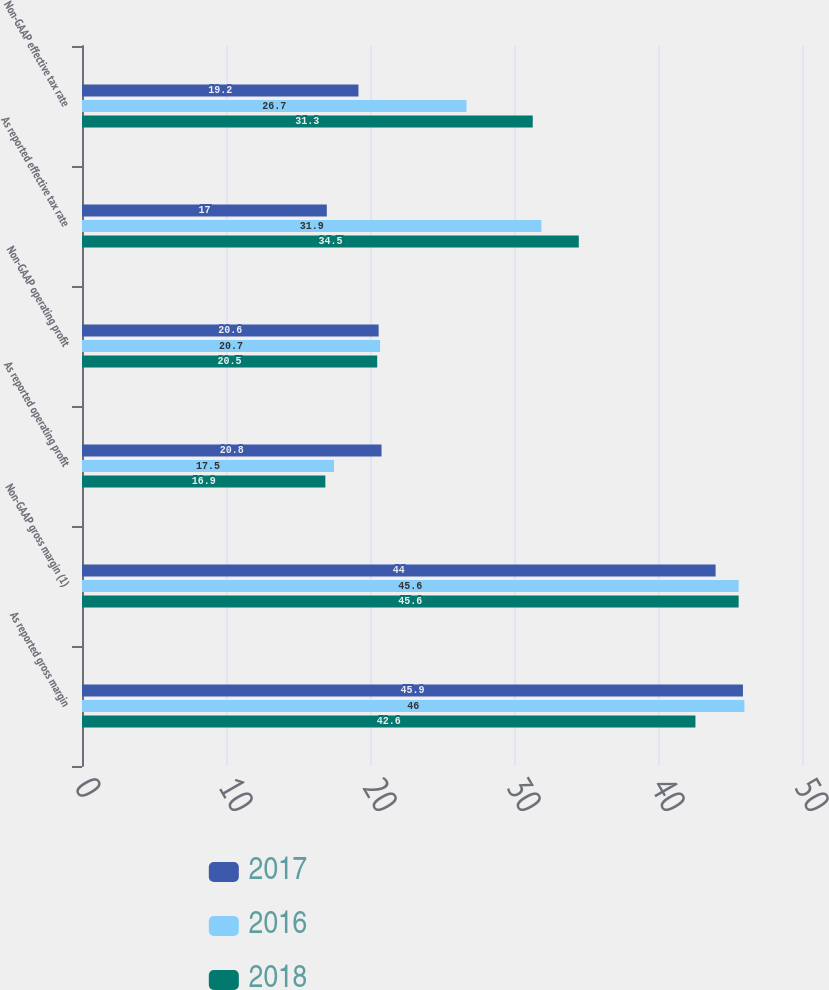<chart> <loc_0><loc_0><loc_500><loc_500><stacked_bar_chart><ecel><fcel>As reported gross margin<fcel>Non-GAAP gross margin (1)<fcel>As reported operating profit<fcel>Non-GAAP operating profit<fcel>As reported effective tax rate<fcel>Non-GAAP effective tax rate<nl><fcel>2017<fcel>45.9<fcel>44<fcel>20.8<fcel>20.6<fcel>17<fcel>19.2<nl><fcel>2016<fcel>46<fcel>45.6<fcel>17.5<fcel>20.7<fcel>31.9<fcel>26.7<nl><fcel>2018<fcel>42.6<fcel>45.6<fcel>16.9<fcel>20.5<fcel>34.5<fcel>31.3<nl></chart> 